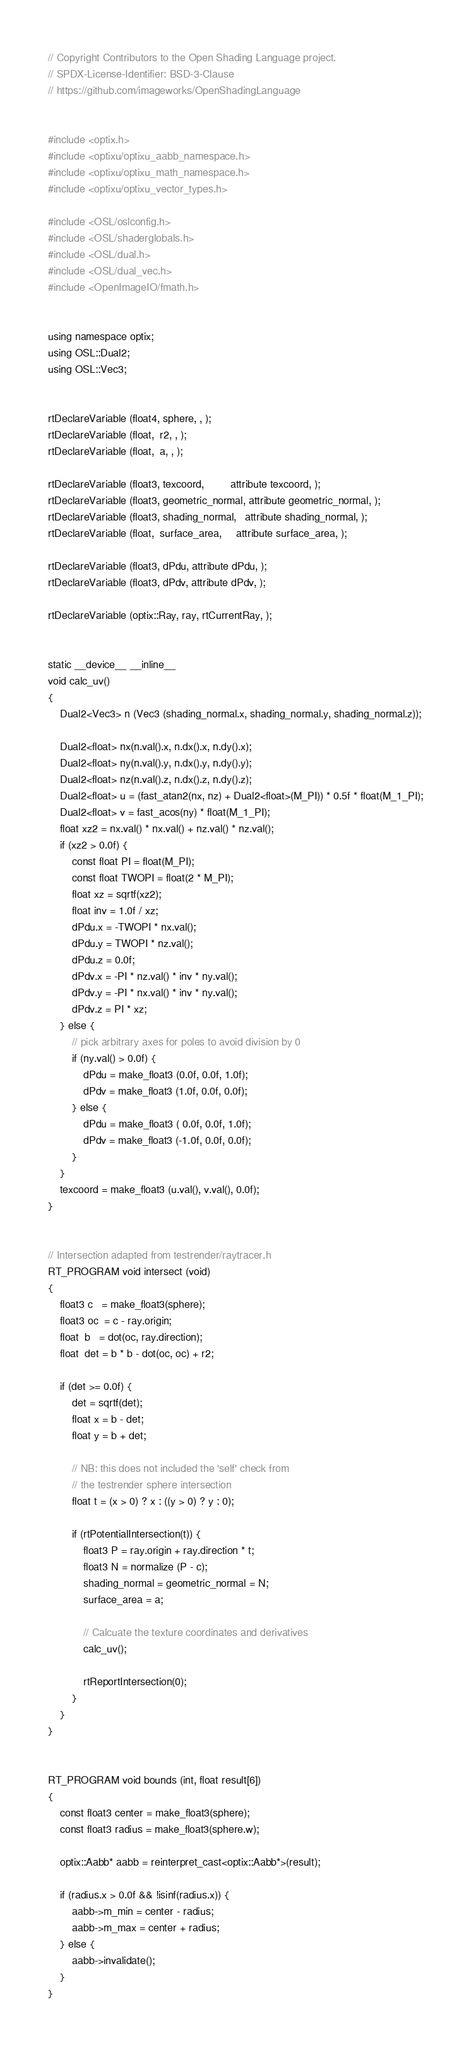Convert code to text. <code><loc_0><loc_0><loc_500><loc_500><_Cuda_>// Copyright Contributors to the Open Shading Language project.
// SPDX-License-Identifier: BSD-3-Clause
// https://github.com/imageworks/OpenShadingLanguage


#include <optix.h>
#include <optixu/optixu_aabb_namespace.h>
#include <optixu/optixu_math_namespace.h>
#include <optixu/optixu_vector_types.h>

#include <OSL/oslconfig.h>
#include <OSL/shaderglobals.h>
#include <OSL/dual.h>
#include <OSL/dual_vec.h>
#include <OpenImageIO/fmath.h>


using namespace optix;
using OSL::Dual2;
using OSL::Vec3;


rtDeclareVariable (float4, sphere, , );
rtDeclareVariable (float,  r2, , );
rtDeclareVariable (float,  a, , );

rtDeclareVariable (float3, texcoord,         attribute texcoord, );
rtDeclareVariable (float3, geometric_normal, attribute geometric_normal, );
rtDeclareVariable (float3, shading_normal,   attribute shading_normal, );
rtDeclareVariable (float,  surface_area,     attribute surface_area, );

rtDeclareVariable (float3, dPdu, attribute dPdu, );
rtDeclareVariable (float3, dPdv, attribute dPdv, );

rtDeclareVariable (optix::Ray, ray, rtCurrentRay, );


static __device__ __inline__
void calc_uv()
{
    Dual2<Vec3> n (Vec3 (shading_normal.x, shading_normal.y, shading_normal.z));

    Dual2<float> nx(n.val().x, n.dx().x, n.dy().x);
    Dual2<float> ny(n.val().y, n.dx().y, n.dy().y);
    Dual2<float> nz(n.val().z, n.dx().z, n.dy().z);
    Dual2<float> u = (fast_atan2(nx, nz) + Dual2<float>(M_PI)) * 0.5f * float(M_1_PI);
    Dual2<float> v = fast_acos(ny) * float(M_1_PI);
    float xz2 = nx.val() * nx.val() + nz.val() * nz.val();
    if (xz2 > 0.0f) {
        const float PI = float(M_PI);
        const float TWOPI = float(2 * M_PI);
        float xz = sqrtf(xz2);
        float inv = 1.0f / xz;
        dPdu.x = -TWOPI * nx.val();
        dPdu.y = TWOPI * nz.val();
        dPdu.z = 0.0f;
        dPdv.x = -PI * nz.val() * inv * ny.val();
        dPdv.y = -PI * nx.val() * inv * ny.val();
        dPdv.z = PI * xz;
    } else {
        // pick arbitrary axes for poles to avoid division by 0
        if (ny.val() > 0.0f) {
            dPdu = make_float3 (0.0f, 0.0f, 1.0f);
            dPdv = make_float3 (1.0f, 0.0f, 0.0f);
        } else {
            dPdu = make_float3 ( 0.0f, 0.0f, 1.0f);
            dPdv = make_float3 (-1.0f, 0.0f, 0.0f);
        }
    }
    texcoord = make_float3 (u.val(), v.val(), 0.0f);
}


// Intersection adapted from testrender/raytracer.h
RT_PROGRAM void intersect (void)
{
    float3 c   = make_float3(sphere);
    float3 oc  = c - ray.origin;
    float  b   = dot(oc, ray.direction);
    float  det = b * b - dot(oc, oc) + r2;

    if (det >= 0.0f) {
        det = sqrtf(det);
        float x = b - det;
        float y = b + det;

        // NB: this does not included the 'self' check from
        // the testrender sphere intersection
        float t = (x > 0) ? x : ((y > 0) ? y : 0);

        if (rtPotentialIntersection(t)) {
            float3 P = ray.origin + ray.direction * t;
            float3 N = normalize (P - c);
            shading_normal = geometric_normal = N;
            surface_area = a;

            // Calcuate the texture coordinates and derivatives
            calc_uv();

            rtReportIntersection(0);
        }
    }
}


RT_PROGRAM void bounds (int, float result[6])
{
    const float3 center = make_float3(sphere);
    const float3 radius = make_float3(sphere.w);

    optix::Aabb* aabb = reinterpret_cast<optix::Aabb*>(result);

    if (radius.x > 0.0f && !isinf(radius.x)) {
        aabb->m_min = center - radius;
        aabb->m_max = center + radius;
    } else {
        aabb->invalidate();
    }
}
</code> 